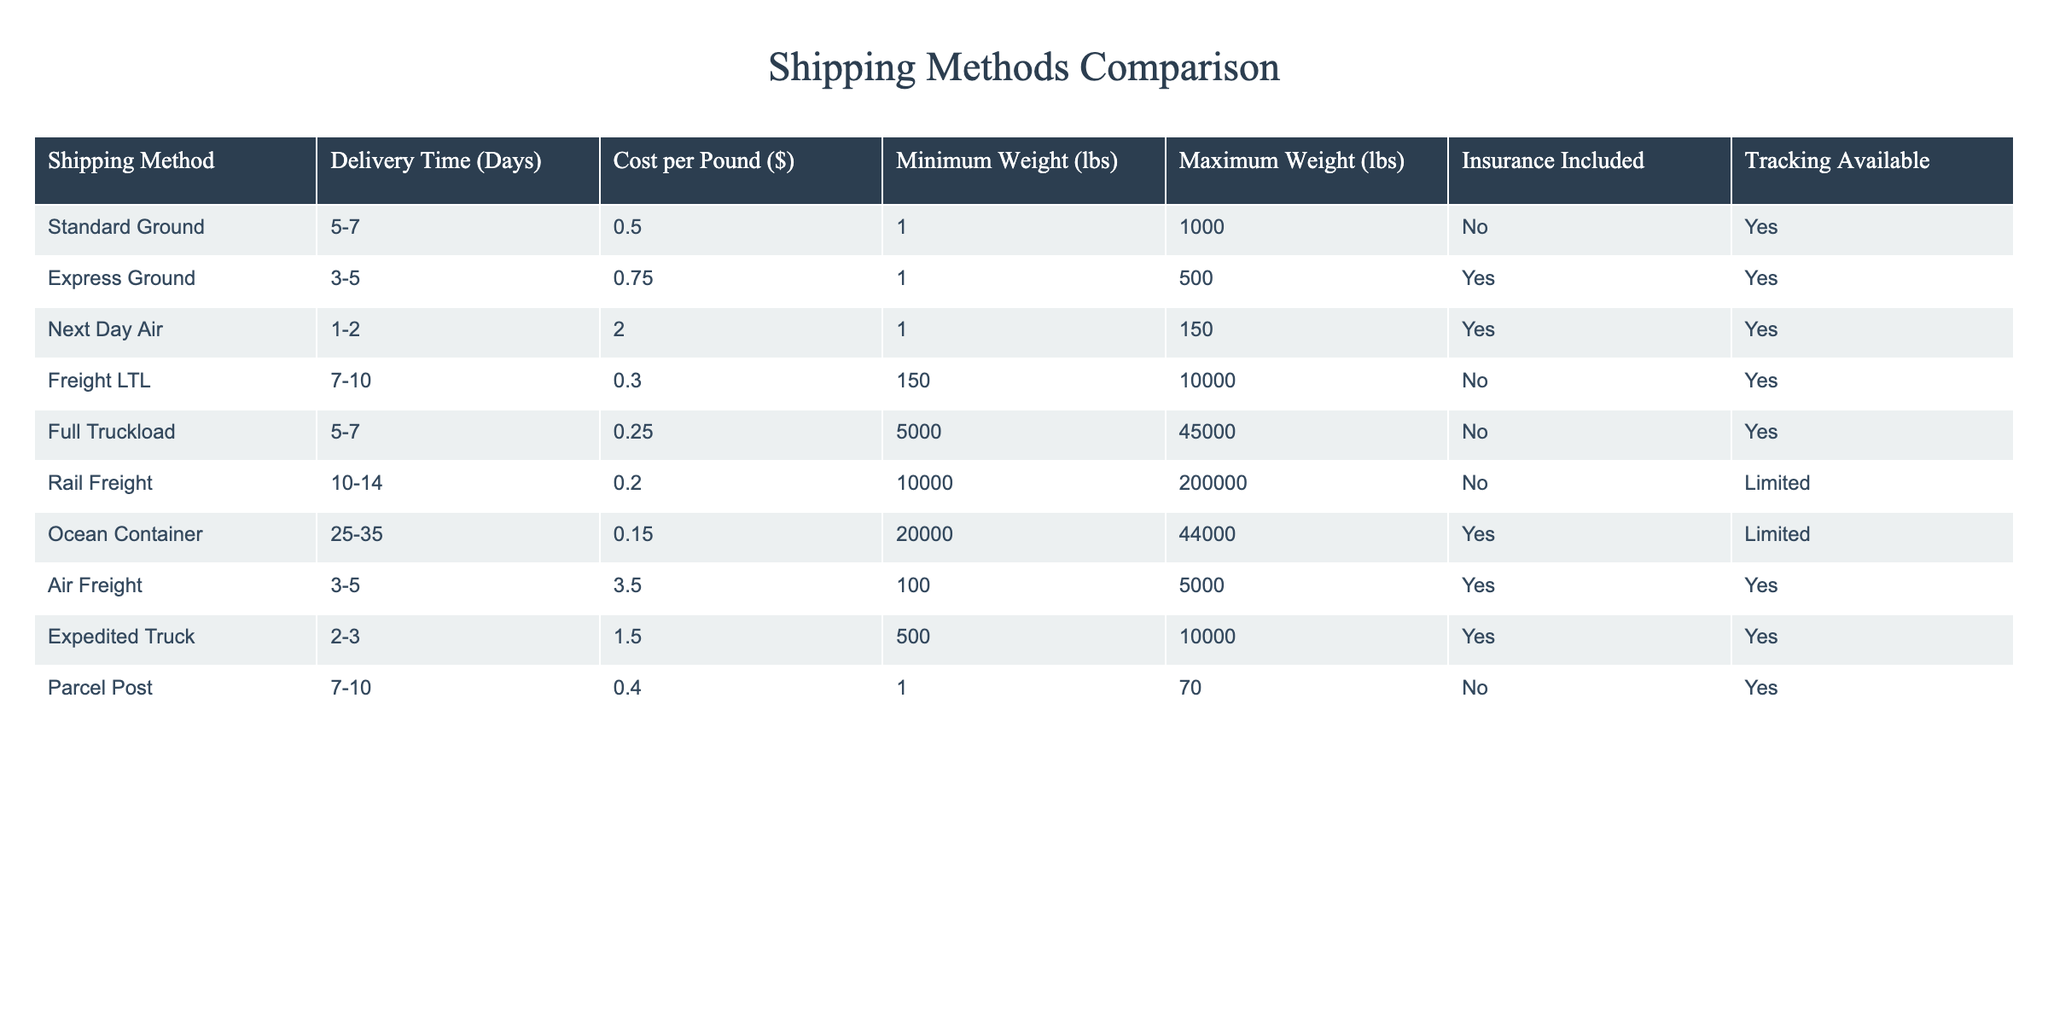What is the delivery time for Next Day Air? The table lists the delivery time for Next Day Air as 1-2 days.
Answer: 1-2 days Which shipping method has the lowest cost per pound? By reviewing the cost per pound column, Freight LTL has the lowest cost at $0.30 per pound.
Answer: $0.30 per pound Is tracking available for Ocean Container shipping? The table indicates that tracking is limited for Ocean Container shipping.
Answer: Limited What is the average delivery time for the Express Ground and Air Freight shipping methods? Delivery times for Express Ground are 3-5 days and for Air Freight are 3-5 days. The average delivery time can be calculated as (3+5) / 2 = 4 days.
Answer: 4 days Does Full Truckload shipping include insurance? A review of the table shows that Full Truckload shipping does not include insurance.
Answer: No What is the cost of shipping 5000 pounds using Full Truckload and Rail Freight? The cost per pound for Full Truckload is $0.25. For 5000 pounds, the total cost is 5000 * $0.25 = $1250. The cost per pound for Rail Freight is $0.20. For 5000 pounds, the total cost is 5000 * $0.20 = $1000. The total cost for both methods is $1250 + $1000 = $2250.
Answer: $2250 How many shipping methods have delivery times of less than 7 days? The shipping methods with delivery times less than 7 days are Next Day Air (1-2 days), Expedited Truck (2-3 days), and Express Ground (3-5 days), totaling 3 methods.
Answer: 3 methods Is there a shipping method that allows for both minimum weight of 1 pound and insurance? A review of the table shows that Express Ground allows for a minimum weight of 1 lb and includes insurance.
Answer: Yes What is the maximum weight limit for Rail Freight and how does it compare to Ocean Container? Rail Freight has a maximum weight limit of 200,000 lbs, while Ocean Container has a maximum weight limit of 44,000 lbs. Rail Freight's limit is significantly higher than Ocean Container's.
Answer: Rail Freight: 200,000 lbs, Ocean Container: 44,000 lbs 